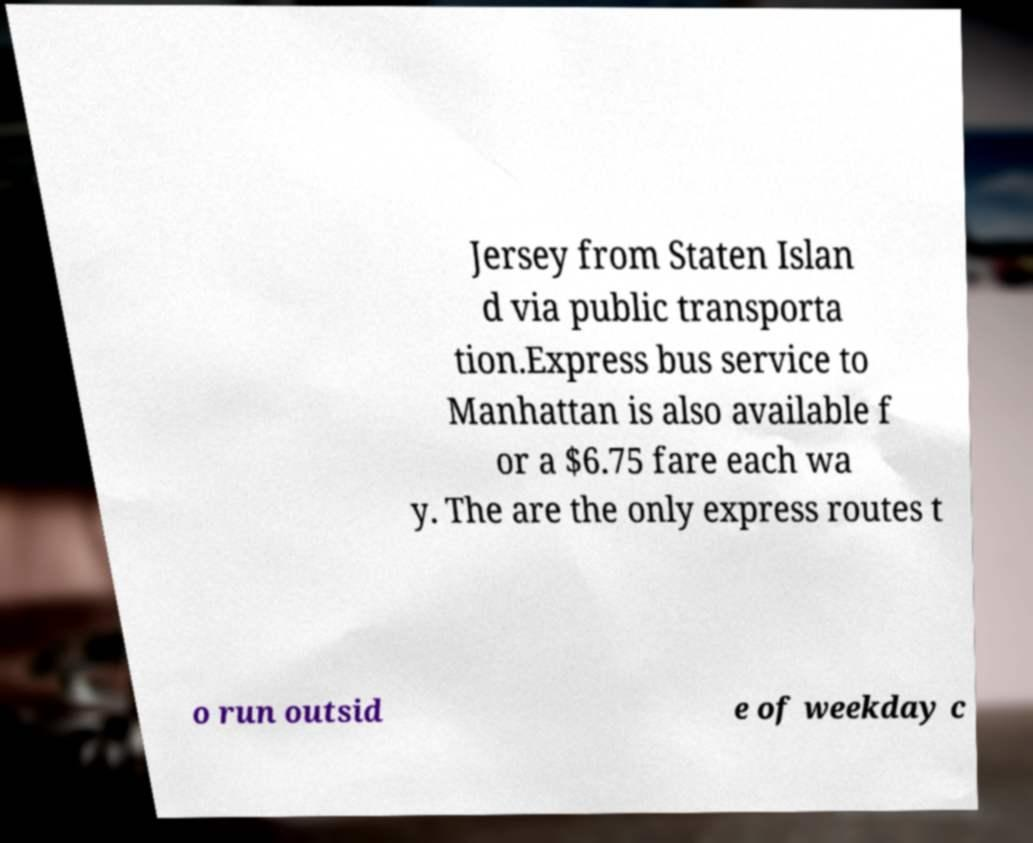There's text embedded in this image that I need extracted. Can you transcribe it verbatim? Jersey from Staten Islan d via public transporta tion.Express bus service to Manhattan is also available f or a $6.75 fare each wa y. The are the only express routes t o run outsid e of weekday c 